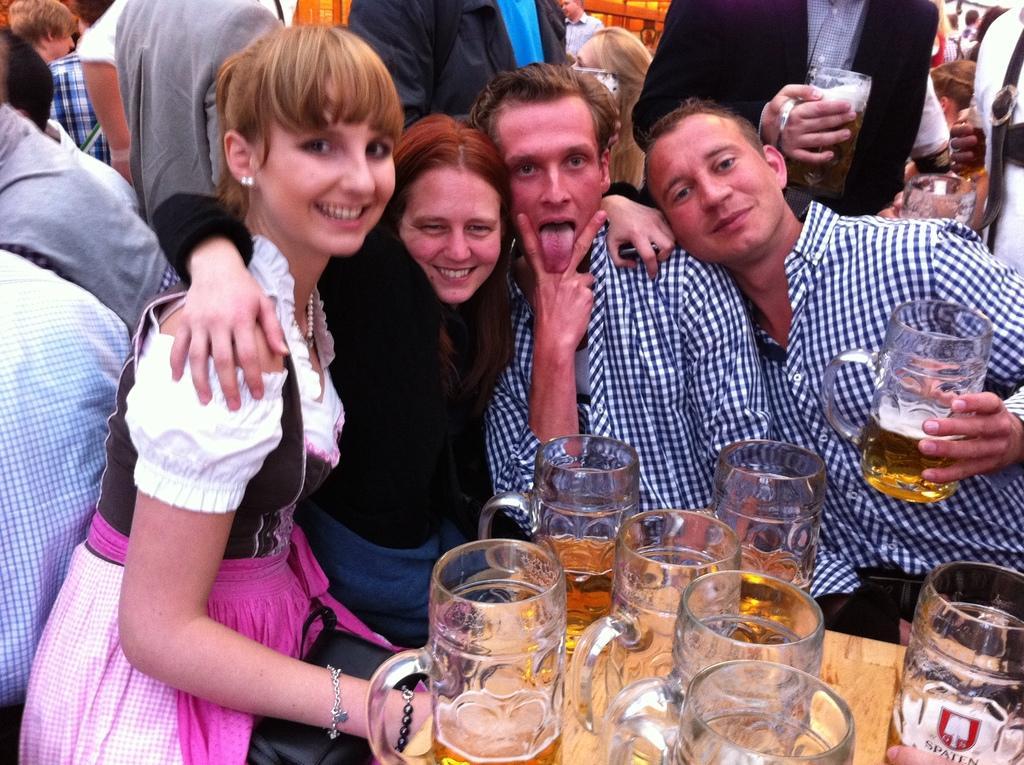In one or two sentences, can you explain what this image depicts? In this image I can see few people are standing, smiling by giving a pose to the picture. In this two are men, two are women. In front of this person's there is a table. On that few wine glasses are there. This is an outside view. Here two men are wearing same shirts. 